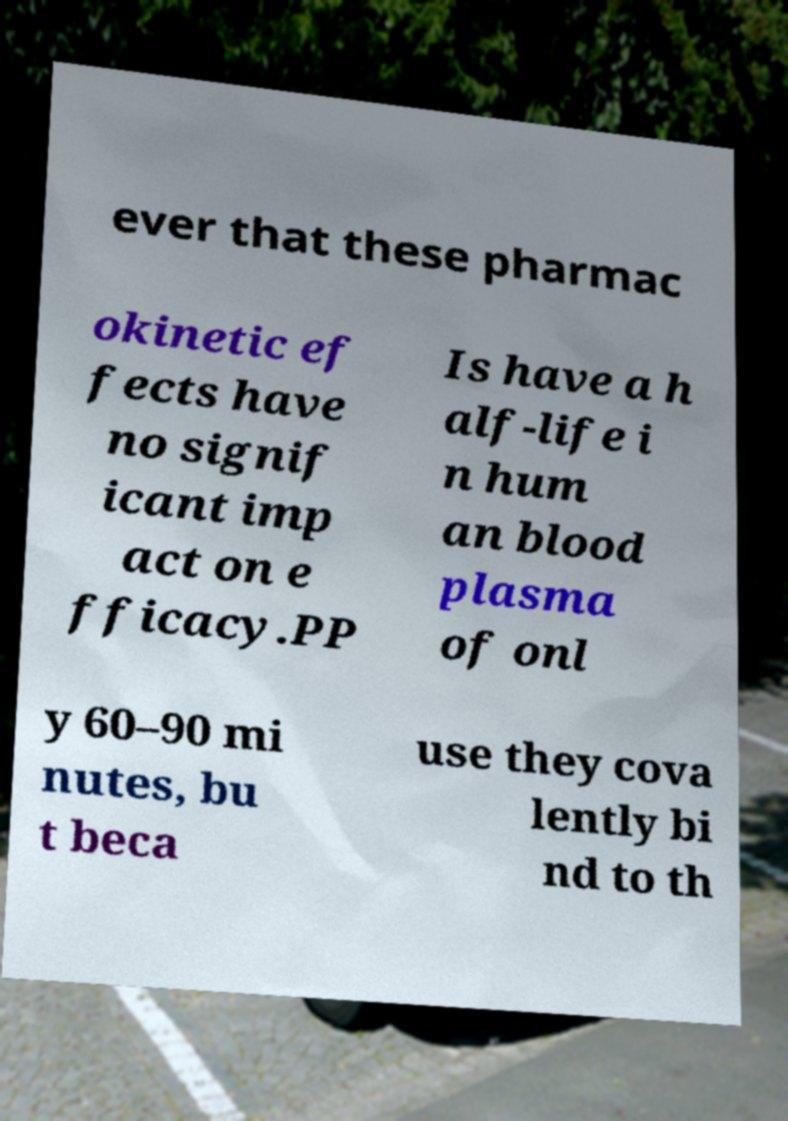Can you accurately transcribe the text from the provided image for me? ever that these pharmac okinetic ef fects have no signif icant imp act on e fficacy.PP Is have a h alf-life i n hum an blood plasma of onl y 60–90 mi nutes, bu t beca use they cova lently bi nd to th 